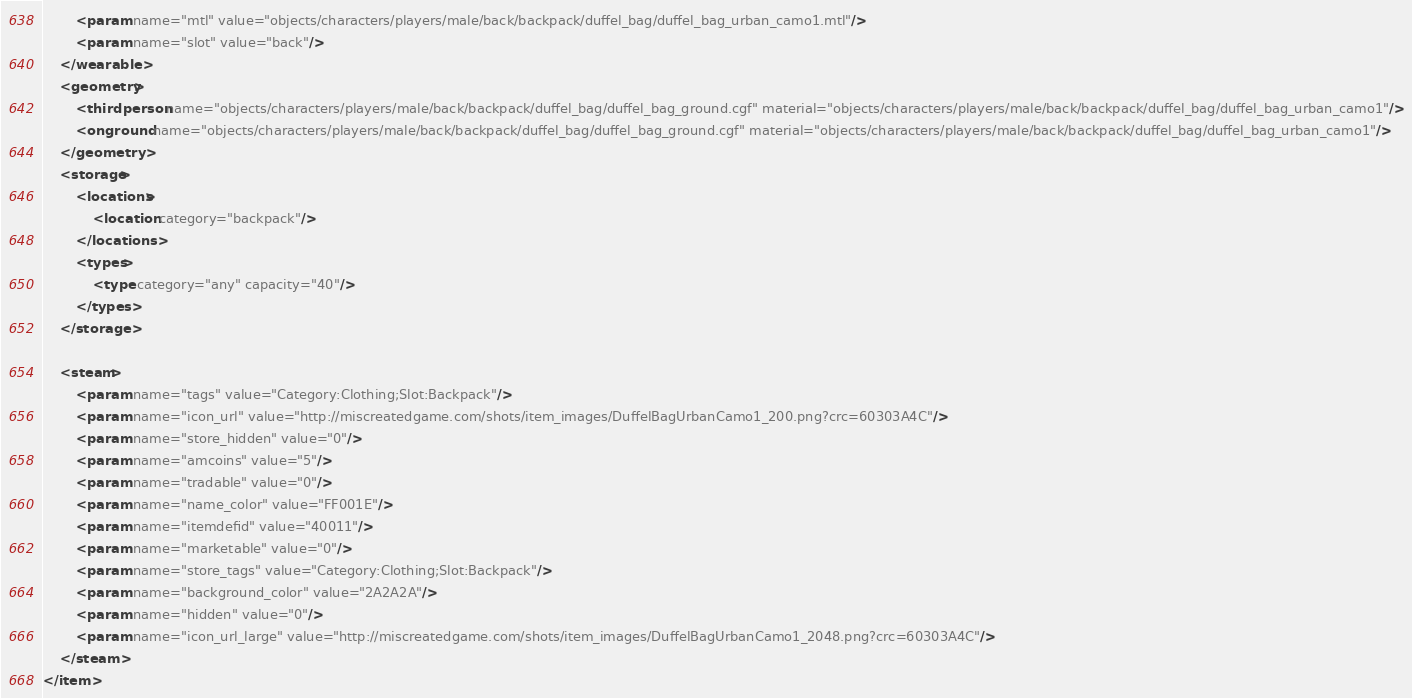<code> <loc_0><loc_0><loc_500><loc_500><_XML_>		<param name="mtl" value="objects/characters/players/male/back/backpack/duffel_bag/duffel_bag_urban_camo1.mtl"/>
		<param name="slot" value="back"/>
	</wearable>
	<geometry>
		<thirdperson name="objects/characters/players/male/back/backpack/duffel_bag/duffel_bag_ground.cgf" material="objects/characters/players/male/back/backpack/duffel_bag/duffel_bag_urban_camo1"/>
		<onground name="objects/characters/players/male/back/backpack/duffel_bag/duffel_bag_ground.cgf" material="objects/characters/players/male/back/backpack/duffel_bag/duffel_bag_urban_camo1"/>
	</geometry>
	<storage>
		<locations>
			<location category="backpack"/>
		</locations>
		<types>
			<type category="any" capacity="40"/>
		</types>
	</storage>

	<steam>
		<param name="tags" value="Category:Clothing;Slot:Backpack"/>
		<param name="icon_url" value="http://miscreatedgame.com/shots/item_images/DuffelBagUrbanCamo1_200.png?crc=60303A4C"/>
		<param name="store_hidden" value="0"/>
		<param name="amcoins" value="5"/>
		<param name="tradable" value="0"/>
		<param name="name_color" value="FF001E"/>
		<param name="itemdefid" value="40011"/>
		<param name="marketable" value="0"/>
		<param name="store_tags" value="Category:Clothing;Slot:Backpack"/>
		<param name="background_color" value="2A2A2A"/>
		<param name="hidden" value="0"/>
		<param name="icon_url_large" value="http://miscreatedgame.com/shots/item_images/DuffelBagUrbanCamo1_2048.png?crc=60303A4C"/>
	</steam>
</item></code> 